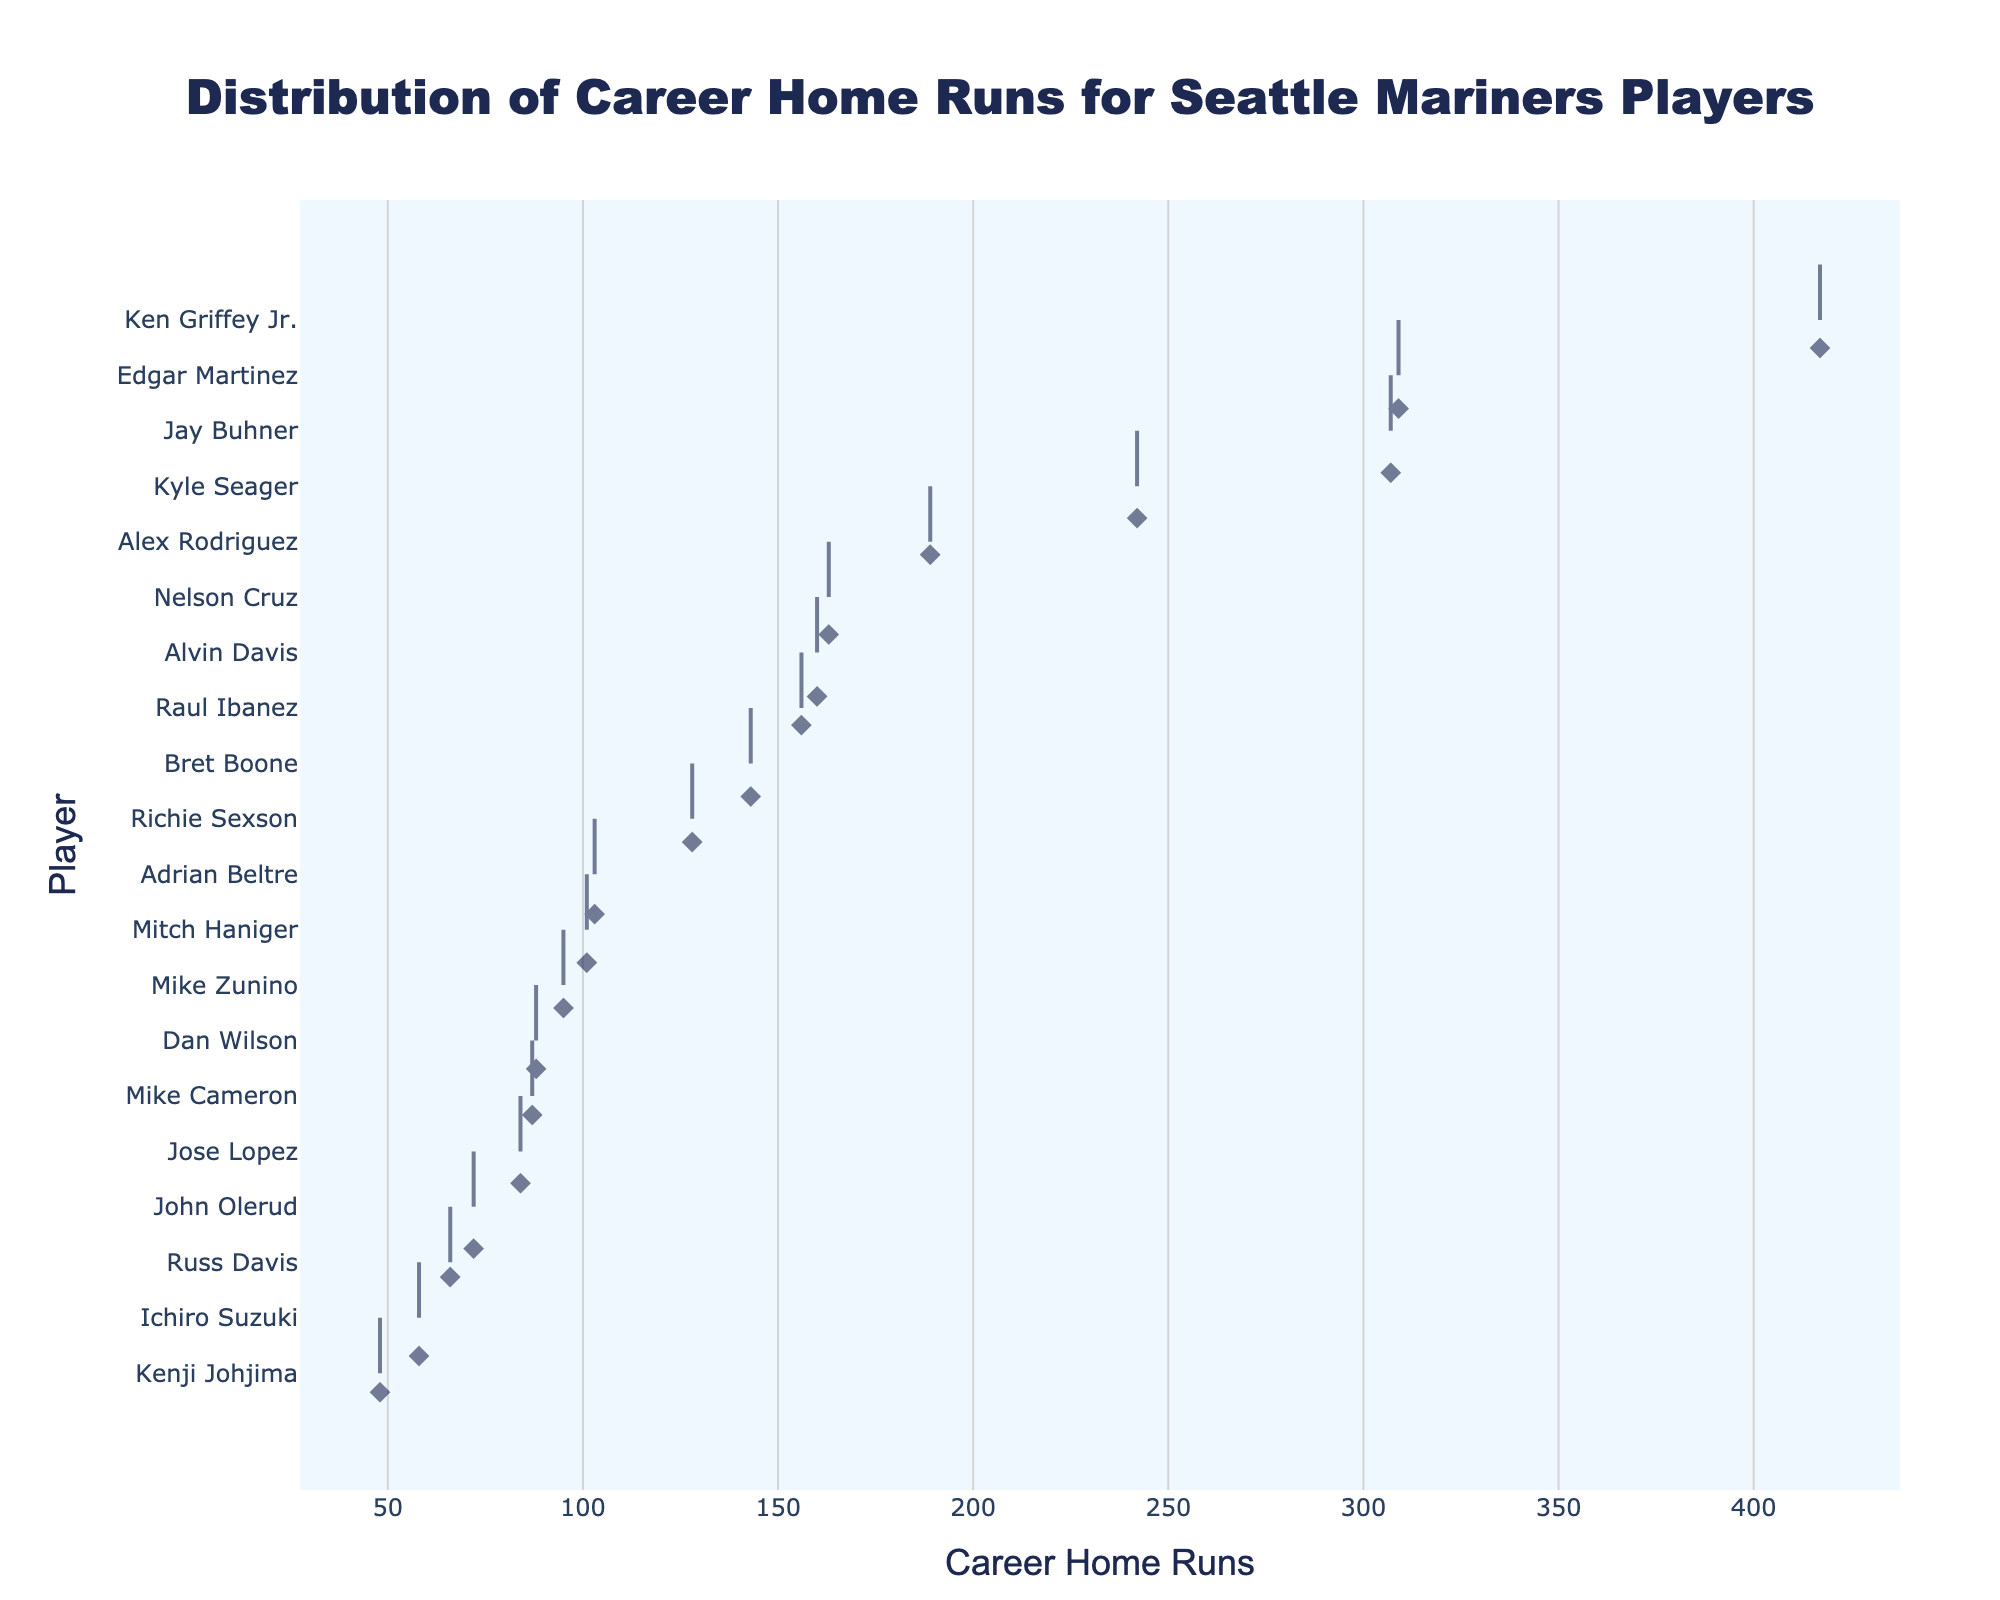What is the title of the plot? The title of the plot is located at the top center of the figure. It reads 'Distribution of Career Home Runs for Seattle Mariners Players'.
Answer: Distribution of Career Home Runs for Seattle Mariners Players Who has the most career home runs among the Seattle Mariners players? By observing the density plot, the player at the topmost position along the y-axis with the highest x-axis value represents the most career home runs. This player is Ken Griffey Jr.
Answer: Ken Griffey Jr What are the x-axis and y-axis titles? The x-axis title is located below the horizontal axis and labeled as 'Career Home Runs', while the y-axis title is located to the left of the vertical axis and labeled as 'Player'.
Answer: Career Home Runs, Player How many players have more than 300 career home runs? Refer to the x-axis and identify the number of players whose home runs exceed the 300 mark. There are two players that match this criterion: Ken Griffey Jr. and Edgar Martinez.
Answer: Two Who has more career home runs, Jay Buhner or Edgar Martinez? To answer this question, compare the positions of Jay Buhner and Edgar Martinez along the x-axis. Edgar Martinez has slightly more career home runs than Jay Buhner.
Answer: Edgar Martinez How many players have less than 100 career home runs? Examine the players' positions relative to the 100 home runs mark on the x-axis. Count the players to the left of this value. There are nine players with less than 100 career home runs.
Answer: Nine Which player has the closest number of career home runs to Mitch Haniger? Locate Mitch Haniger on the plot and identify the adjacent players. The closest player in terms of home runs to Mitch Haniger is Adrian Beltre.
Answer: Adrian Beltre What is the difference in career home runs between Alex Rodriguez and Nelson Cruz? Find the positions of Alex Rodriguez and Nelson Cruz along the x-axis. Alex Rodriguez has 189 home runs, and Nelson Cruz has 163 home runs. The difference is calculated as 189 - 163.
Answer: 26 Do more players have career home runs closer to 50 or closer to 150? Assess the density of points near the 50 and 150 home runs marks on the x-axis. There are more players concentrated around the 150 home runs mark compared to the 50 home runs mark.
Answer: 150 Who has the least number of career home runs according to the distribution? The player at the bottom of the list on the y-axis represents the one with the fewest career home runs. This player is Kenji Johjima.
Answer: Kenji Johjima 